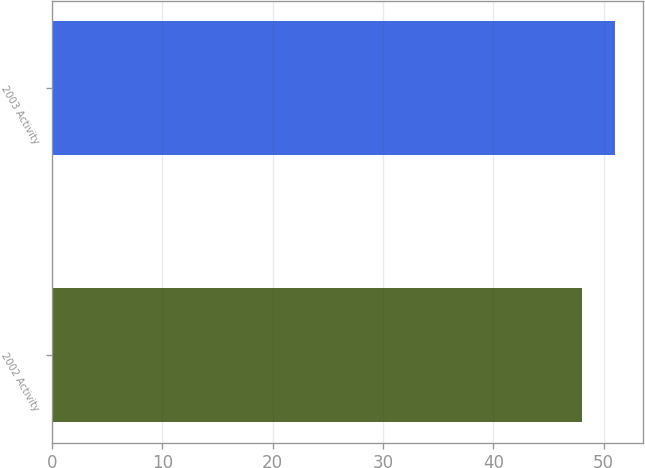Convert chart. <chart><loc_0><loc_0><loc_500><loc_500><bar_chart><fcel>2002 Activity<fcel>2003 Activity<nl><fcel>48<fcel>51<nl></chart> 